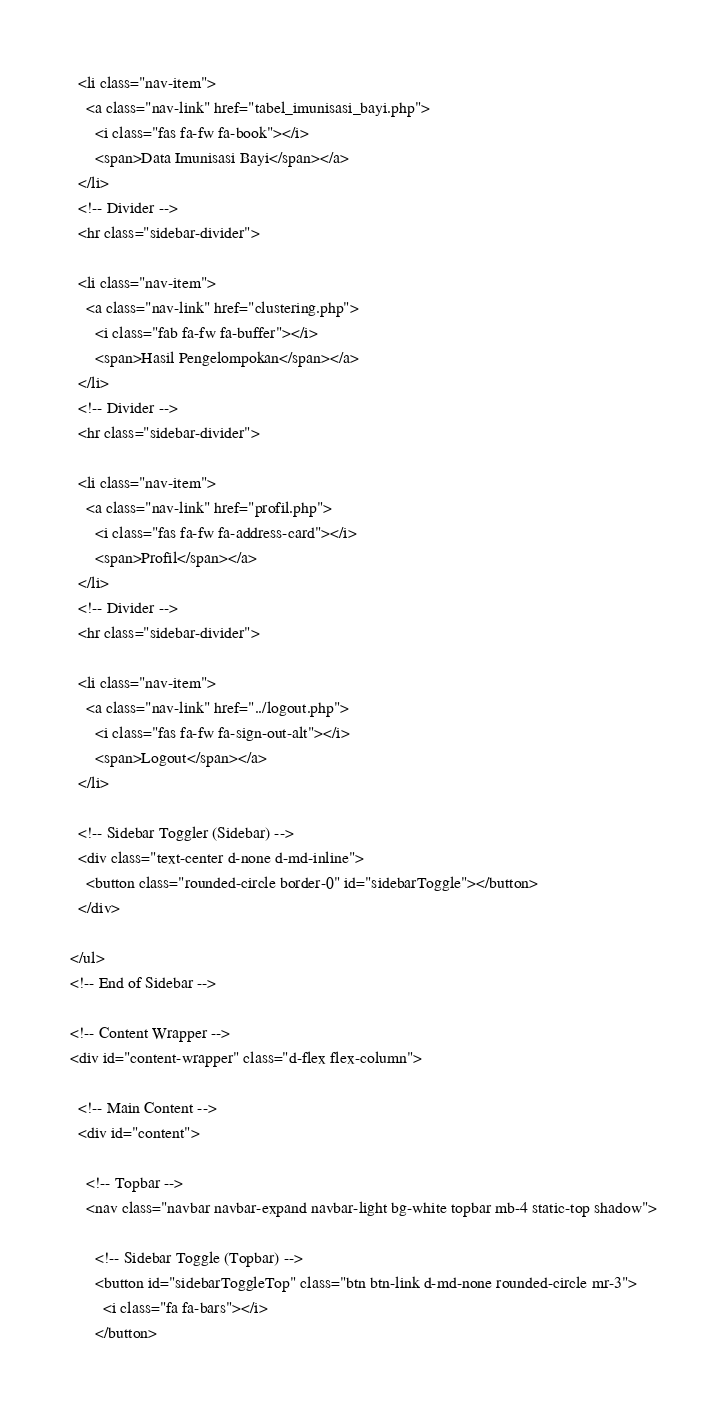<code> <loc_0><loc_0><loc_500><loc_500><_PHP_>  <li class="nav-item">
    <a class="nav-link" href="tabel_imunisasi_bayi.php">
      <i class="fas fa-fw fa-book"></i>
      <span>Data Imunisasi Bayi</span></a>
  </li>
  <!-- Divider -->
  <hr class="sidebar-divider">

  <li class="nav-item">
    <a class="nav-link" href="clustering.php">
      <i class="fab fa-fw fa-buffer"></i>
      <span>Hasil Pengelompokan</span></a>
  </li>
  <!-- Divider -->
  <hr class="sidebar-divider">

  <li class="nav-item">
    <a class="nav-link" href="profil.php">
      <i class="fas fa-fw fa-address-card"></i>
      <span>Profil</span></a>
  </li>
  <!-- Divider -->
  <hr class="sidebar-divider">

  <li class="nav-item">
    <a class="nav-link" href="../logout.php">
      <i class="fas fa-fw fa-sign-out-alt"></i>
      <span>Logout</span></a>
  </li>

  <!-- Sidebar Toggler (Sidebar) -->
  <div class="text-center d-none d-md-inline">
    <button class="rounded-circle border-0" id="sidebarToggle"></button>
  </div>

</ul>
<!-- End of Sidebar -->

<!-- Content Wrapper -->
<div id="content-wrapper" class="d-flex flex-column">

  <!-- Main Content -->
  <div id="content">

    <!-- Topbar -->
    <nav class="navbar navbar-expand navbar-light bg-white topbar mb-4 static-top shadow">

      <!-- Sidebar Toggle (Topbar) -->
      <button id="sidebarToggleTop" class="btn btn-link d-md-none rounded-circle mr-3">
        <i class="fa fa-bars"></i>
      </button></code> 